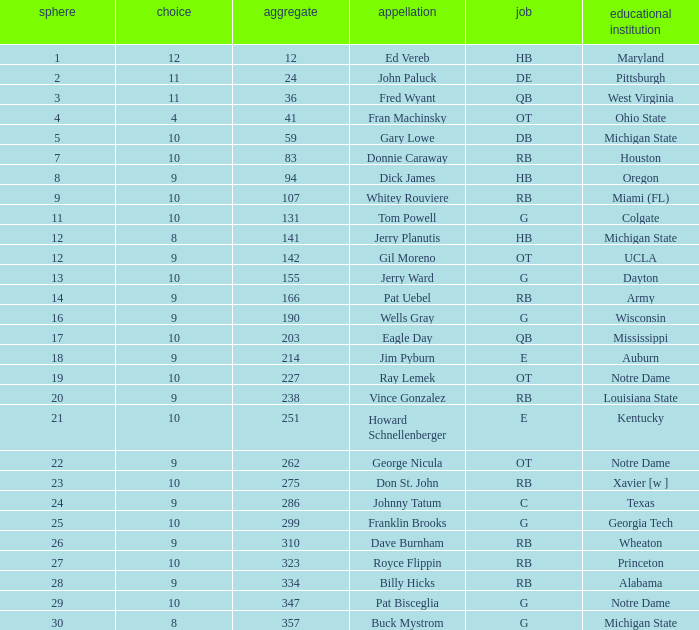What is the highest round number for donnie caraway? 7.0. 